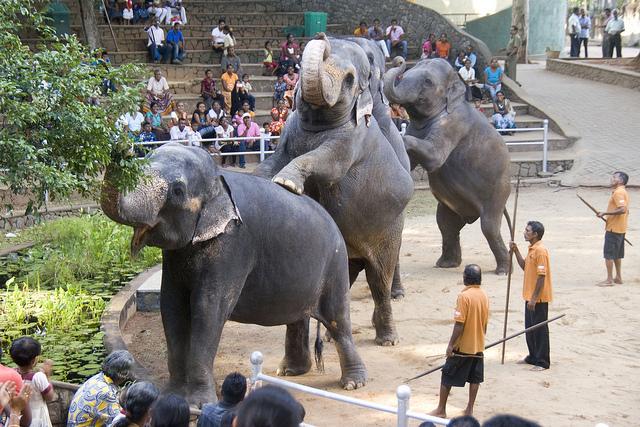What are these animals?
Concise answer only. Elephants. Where they trained to do this?
Short answer required. Yes. Are they at a circus?
Quick response, please. Yes. 